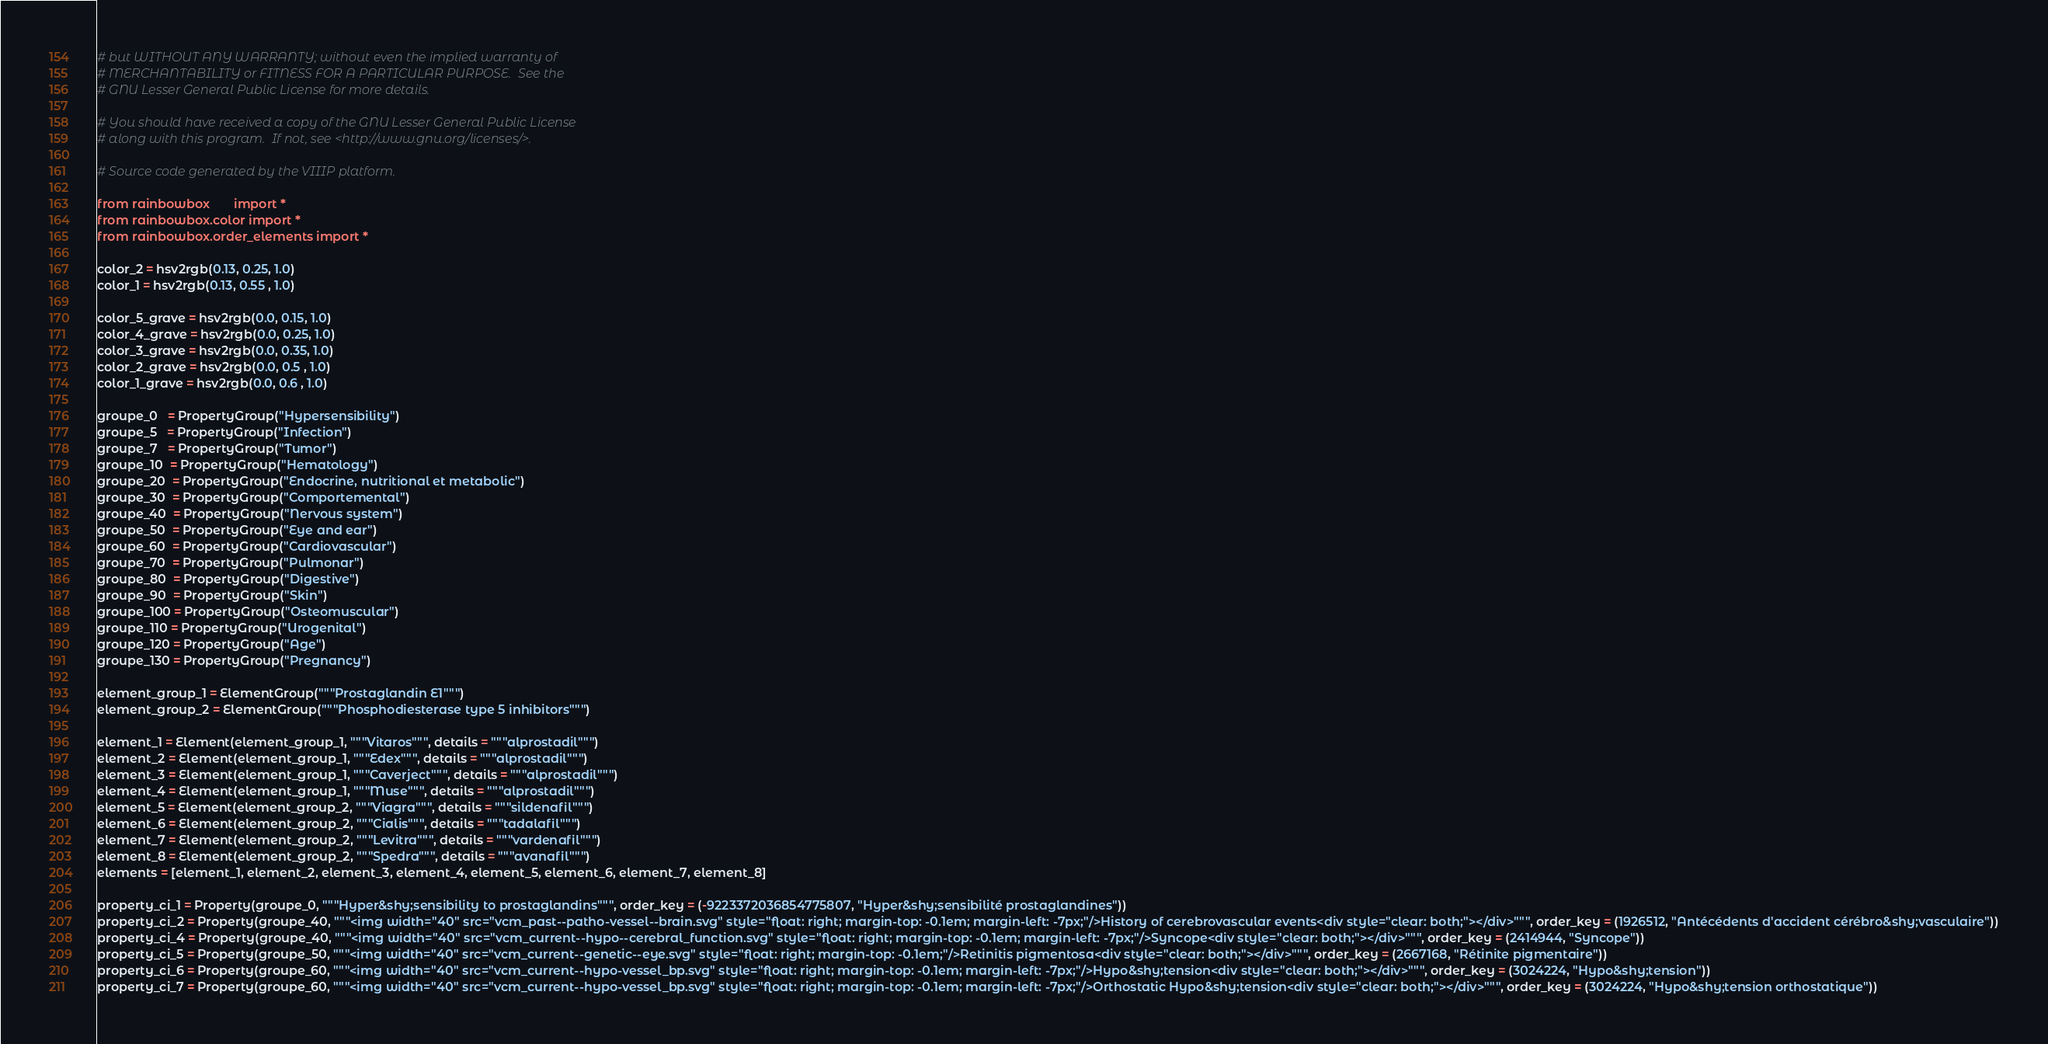Convert code to text. <code><loc_0><loc_0><loc_500><loc_500><_Python_># but WITHOUT ANY WARRANTY; without even the implied warranty of
# MERCHANTABILITY or FITNESS FOR A PARTICULAR PURPOSE.  See the
# GNU Lesser General Public License for more details.

# You should have received a copy of the GNU Lesser General Public License
# along with this program.  If not, see <http://www.gnu.org/licenses/>.

# Source code generated by the VIIIP platform.

from rainbowbox       import *
from rainbowbox.color import *
from rainbowbox.order_elements import *

color_2 = hsv2rgb(0.13, 0.25, 1.0)
color_1 = hsv2rgb(0.13, 0.55 , 1.0)

color_5_grave = hsv2rgb(0.0, 0.15, 1.0)
color_4_grave = hsv2rgb(0.0, 0.25, 1.0)
color_3_grave = hsv2rgb(0.0, 0.35, 1.0)
color_2_grave = hsv2rgb(0.0, 0.5 , 1.0)
color_1_grave = hsv2rgb(0.0, 0.6 , 1.0)

groupe_0   = PropertyGroup("Hypersensibility")
groupe_5   = PropertyGroup("Infection")
groupe_7   = PropertyGroup("Tumor")
groupe_10  = PropertyGroup("Hematology")
groupe_20  = PropertyGroup("Endocrine, nutritional et metabolic")
groupe_30  = PropertyGroup("Comportemental")
groupe_40  = PropertyGroup("Nervous system")
groupe_50  = PropertyGroup("Eye and ear")
groupe_60  = PropertyGroup("Cardiovascular")
groupe_70  = PropertyGroup("Pulmonar")
groupe_80  = PropertyGroup("Digestive")
groupe_90  = PropertyGroup("Skin")
groupe_100 = PropertyGroup("Osteomuscular")
groupe_110 = PropertyGroup("Urogenital")
groupe_120 = PropertyGroup("Age")
groupe_130 = PropertyGroup("Pregnancy")

element_group_1 = ElementGroup("""Prostaglandin E1""")
element_group_2 = ElementGroup("""Phosphodiesterase type 5 inhibitors""")

element_1 = Element(element_group_1, """Vitaros""", details = """alprostadil""")
element_2 = Element(element_group_1, """Edex""", details = """alprostadil""")
element_3 = Element(element_group_1, """Caverject""", details = """alprostadil""")
element_4 = Element(element_group_1, """Muse""", details = """alprostadil""")
element_5 = Element(element_group_2, """Viagra""", details = """sildenafil""")
element_6 = Element(element_group_2, """Cialis""", details = """tadalafil""")
element_7 = Element(element_group_2, """Levitra""", details = """vardenafil""")
element_8 = Element(element_group_2, """Spedra""", details = """avanafil""")
elements = [element_1, element_2, element_3, element_4, element_5, element_6, element_7, element_8]

property_ci_1 = Property(groupe_0, """Hyper&shy;sensibility to prostaglandins""", order_key = (-9223372036854775807, "Hyper&shy;sensibilité prostaglandines"))
property_ci_2 = Property(groupe_40, """<img width="40" src="vcm_past--patho-vessel--brain.svg" style="float: right; margin-top: -0.1em; margin-left: -7px;"/>History of cerebrovascular events<div style="clear: both;"></div>""", order_key = (1926512, "Antécédents d'accident cérébro&shy;vasculaire"))
property_ci_4 = Property(groupe_40, """<img width="40" src="vcm_current--hypo--cerebral_function.svg" style="float: right; margin-top: -0.1em; margin-left: -7px;"/>Syncope<div style="clear: both;"></div>""", order_key = (2414944, "Syncope"))
property_ci_5 = Property(groupe_50, """<img width="40" src="vcm_current--genetic--eye.svg" style="float: right; margin-top: -0.1em;"/>Retinitis pigmentosa<div style="clear: both;"></div>""", order_key = (2667168, "Rétinite pigmentaire"))
property_ci_6 = Property(groupe_60, """<img width="40" src="vcm_current--hypo-vessel_bp.svg" style="float: right; margin-top: -0.1em; margin-left: -7px;"/>Hypo&shy;tension<div style="clear: both;"></div>""", order_key = (3024224, "Hypo&shy;tension"))
property_ci_7 = Property(groupe_60, """<img width="40" src="vcm_current--hypo-vessel_bp.svg" style="float: right; margin-top: -0.1em; margin-left: -7px;"/>Orthostatic Hypo&shy;tension<div style="clear: both;"></div>""", order_key = (3024224, "Hypo&shy;tension orthostatique"))</code> 